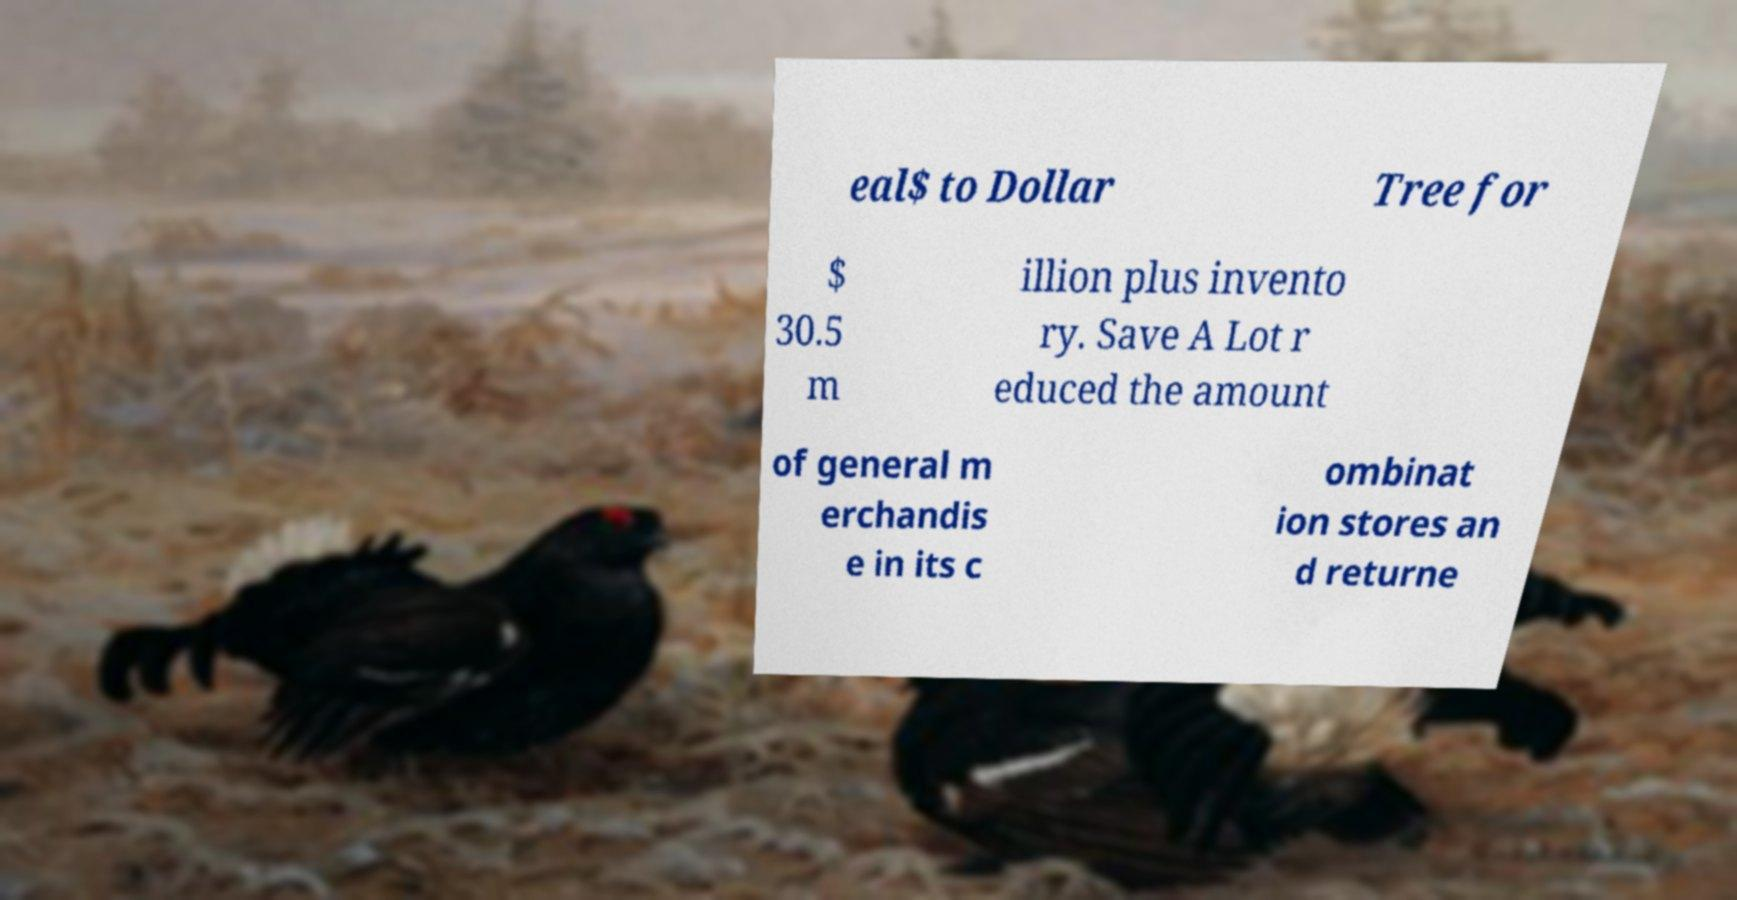Can you read and provide the text displayed in the image?This photo seems to have some interesting text. Can you extract and type it out for me? eal$ to Dollar Tree for $ 30.5 m illion plus invento ry. Save A Lot r educed the amount of general m erchandis e in its c ombinat ion stores an d returne 